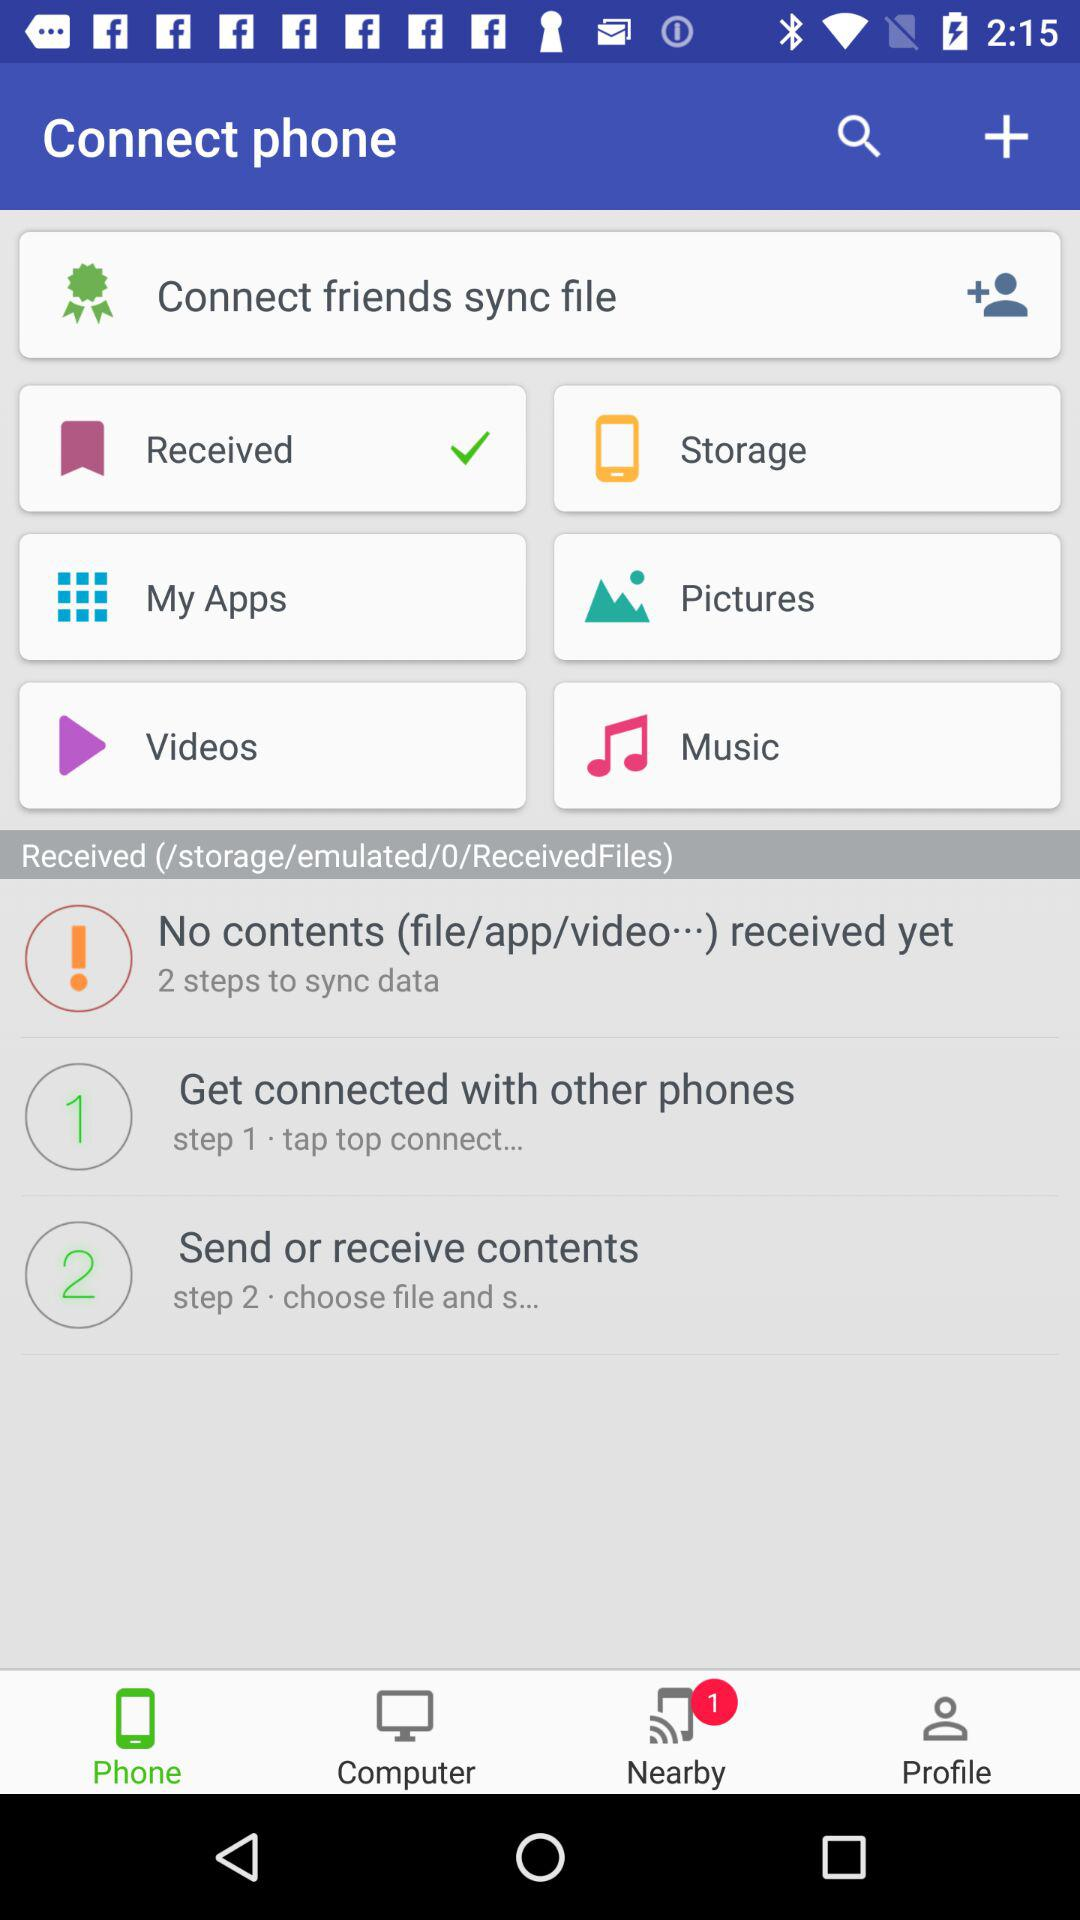Which tab has been selected? The selected tab is "Phone". 